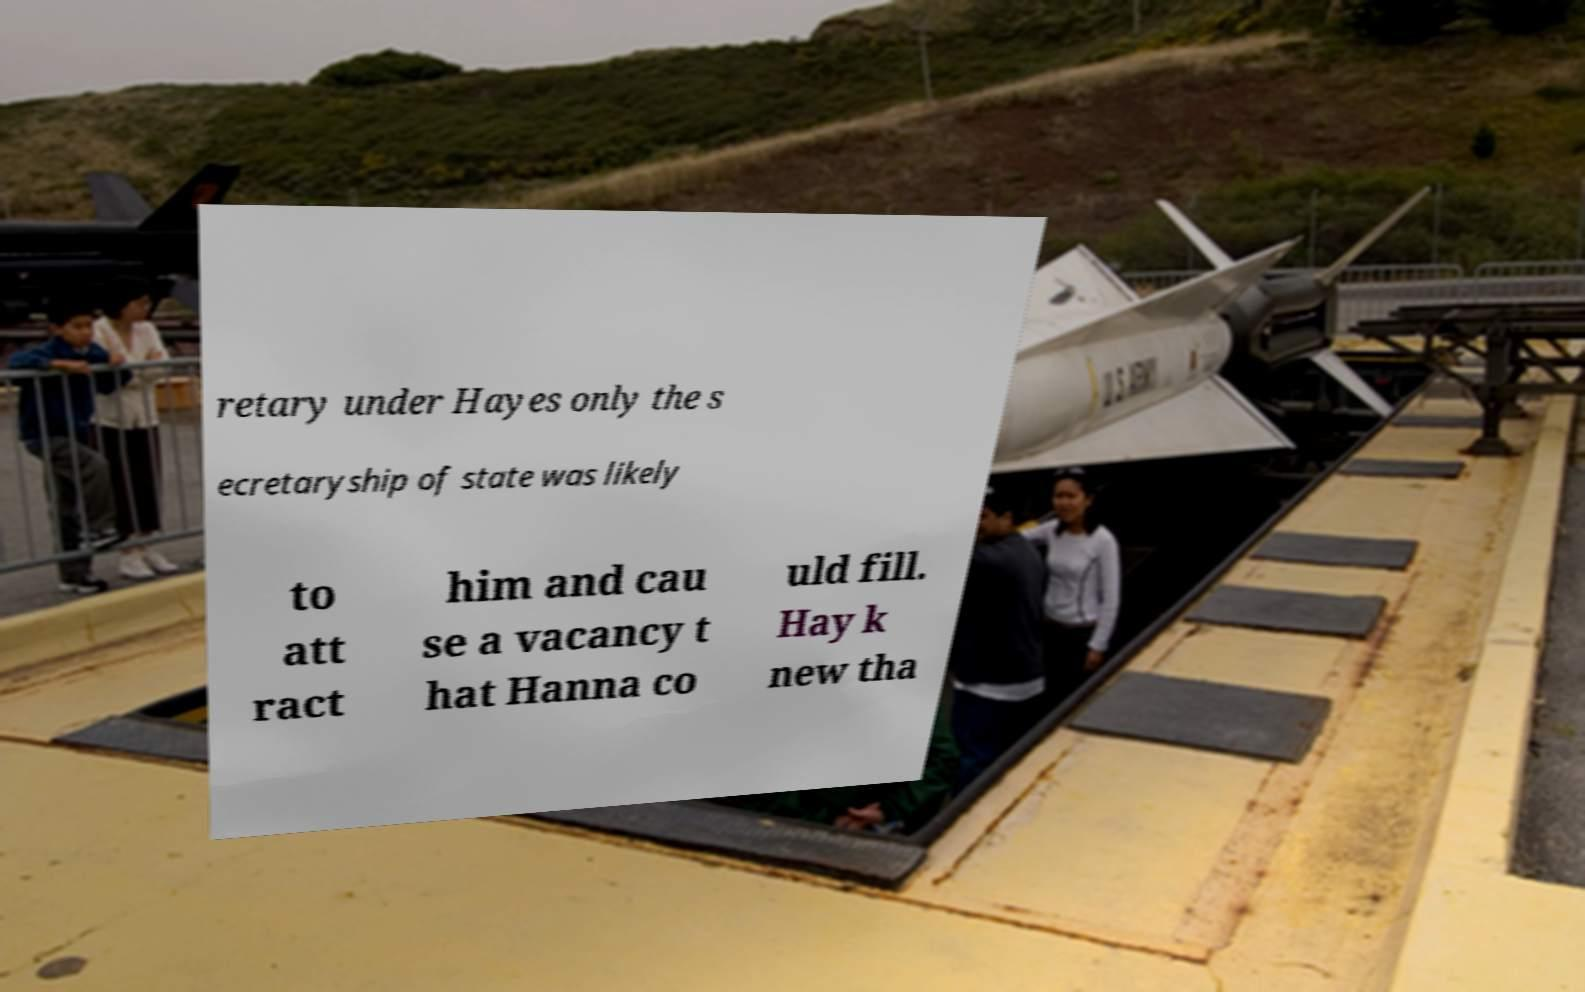Please identify and transcribe the text found in this image. retary under Hayes only the s ecretaryship of state was likely to att ract him and cau se a vacancy t hat Hanna co uld fill. Hay k new tha 